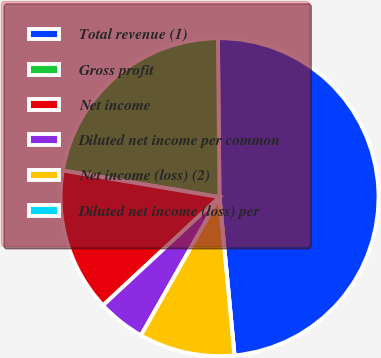Convert chart. <chart><loc_0><loc_0><loc_500><loc_500><pie_chart><fcel>Total revenue (1)<fcel>Gross profit<fcel>Net income<fcel>Diluted net income per common<fcel>Net income (loss) (2)<fcel>Diluted net income (loss) per<nl><fcel>48.65%<fcel>22.16%<fcel>14.59%<fcel>4.86%<fcel>9.73%<fcel>0.0%<nl></chart> 